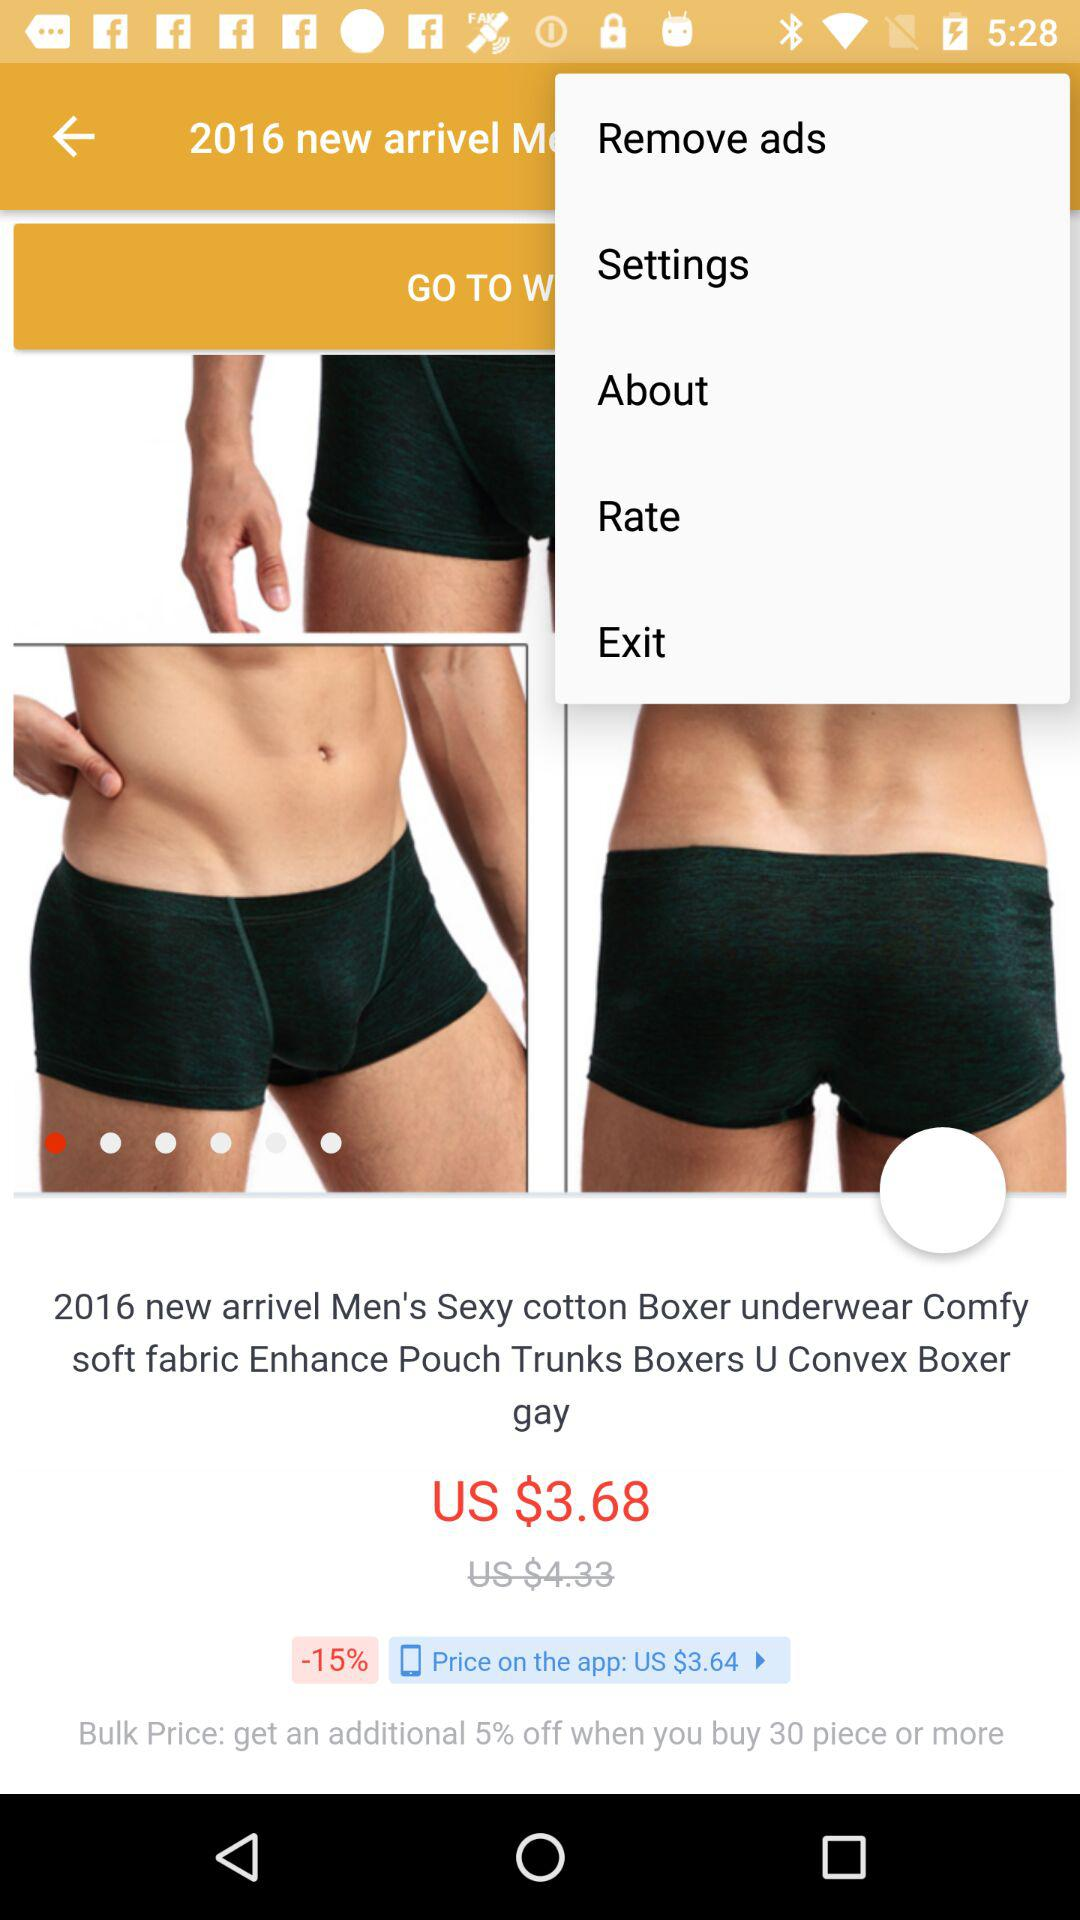What is the currency of price? The currency is US$. 